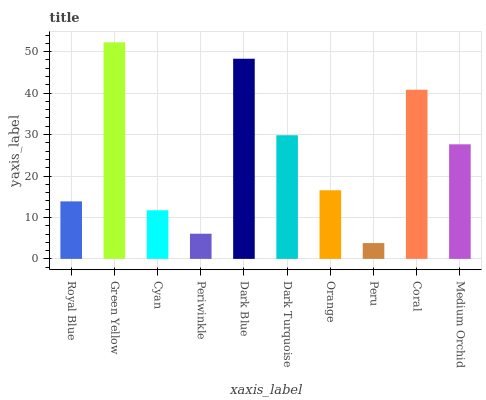Is Peru the minimum?
Answer yes or no. Yes. Is Green Yellow the maximum?
Answer yes or no. Yes. Is Cyan the minimum?
Answer yes or no. No. Is Cyan the maximum?
Answer yes or no. No. Is Green Yellow greater than Cyan?
Answer yes or no. Yes. Is Cyan less than Green Yellow?
Answer yes or no. Yes. Is Cyan greater than Green Yellow?
Answer yes or no. No. Is Green Yellow less than Cyan?
Answer yes or no. No. Is Medium Orchid the high median?
Answer yes or no. Yes. Is Orange the low median?
Answer yes or no. Yes. Is Dark Turquoise the high median?
Answer yes or no. No. Is Dark Turquoise the low median?
Answer yes or no. No. 